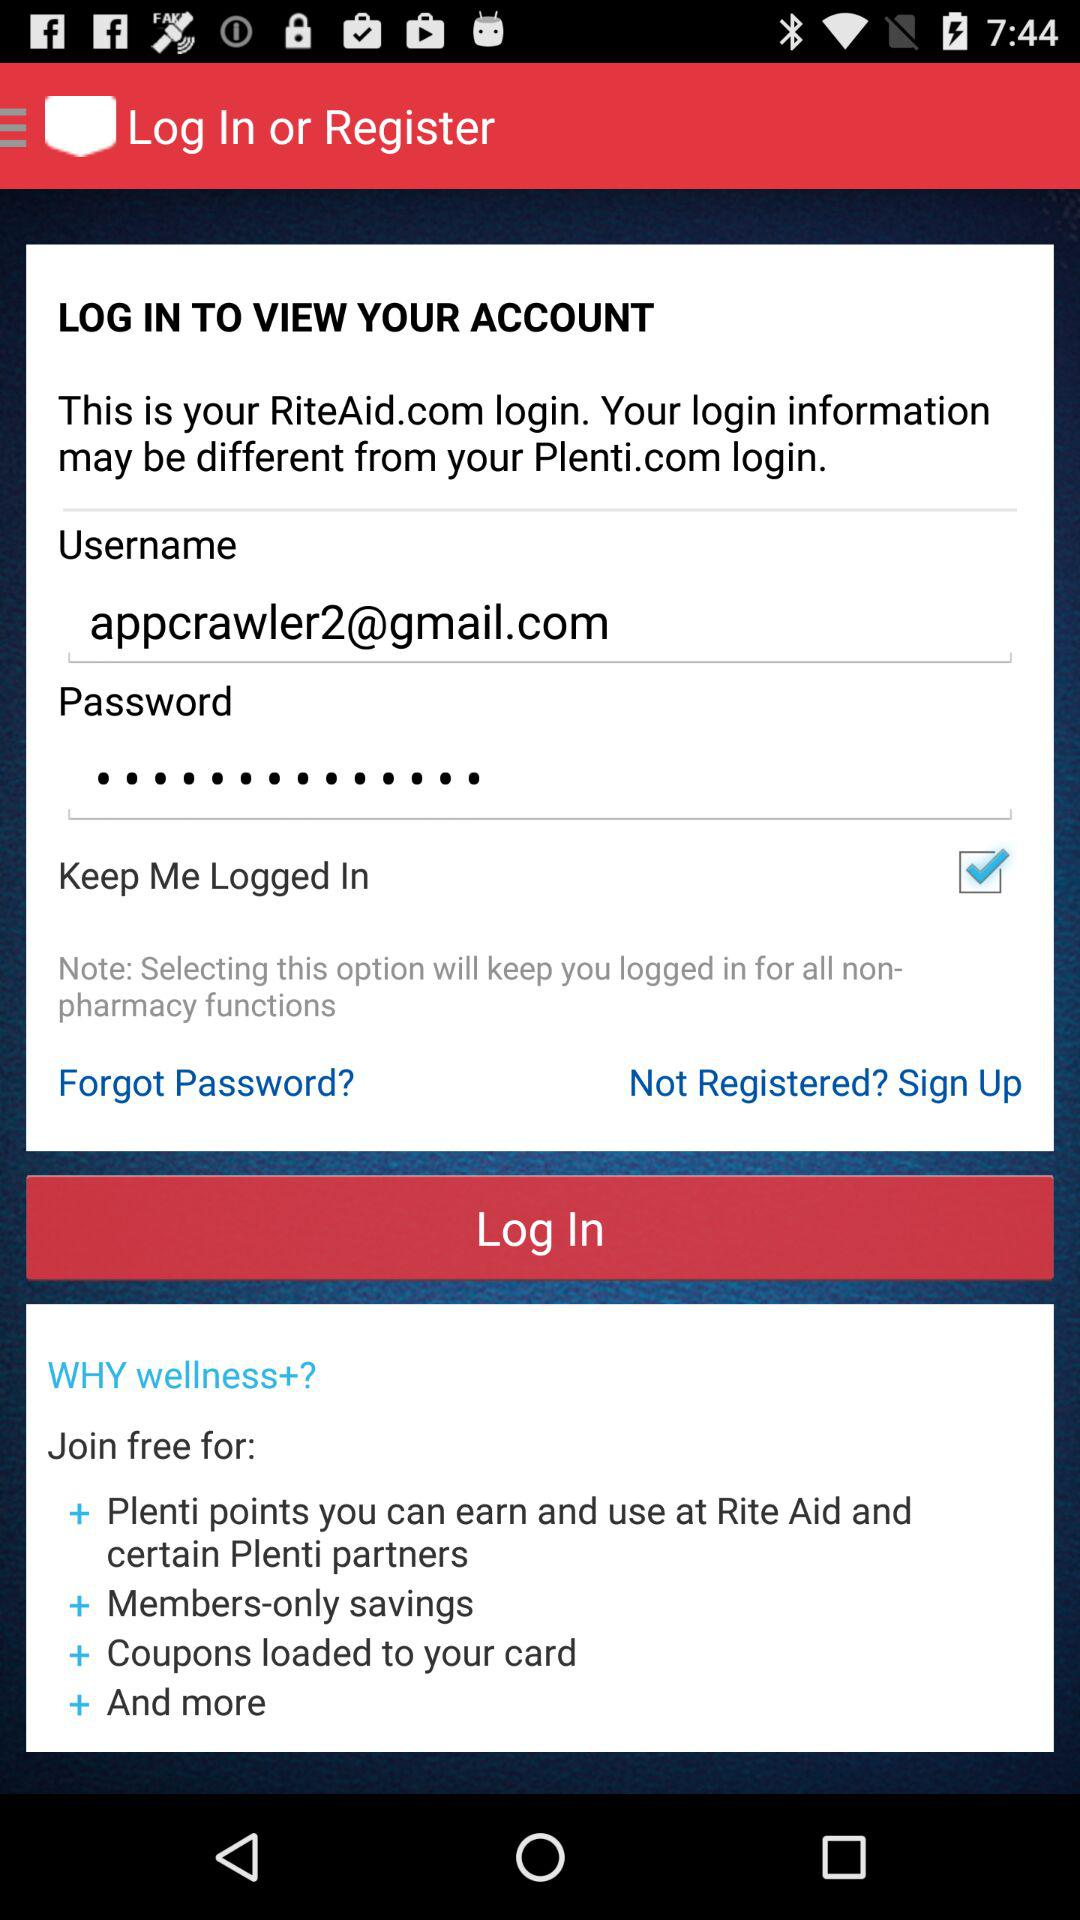What is the username? The username is appcrawler2@gmail.com. 